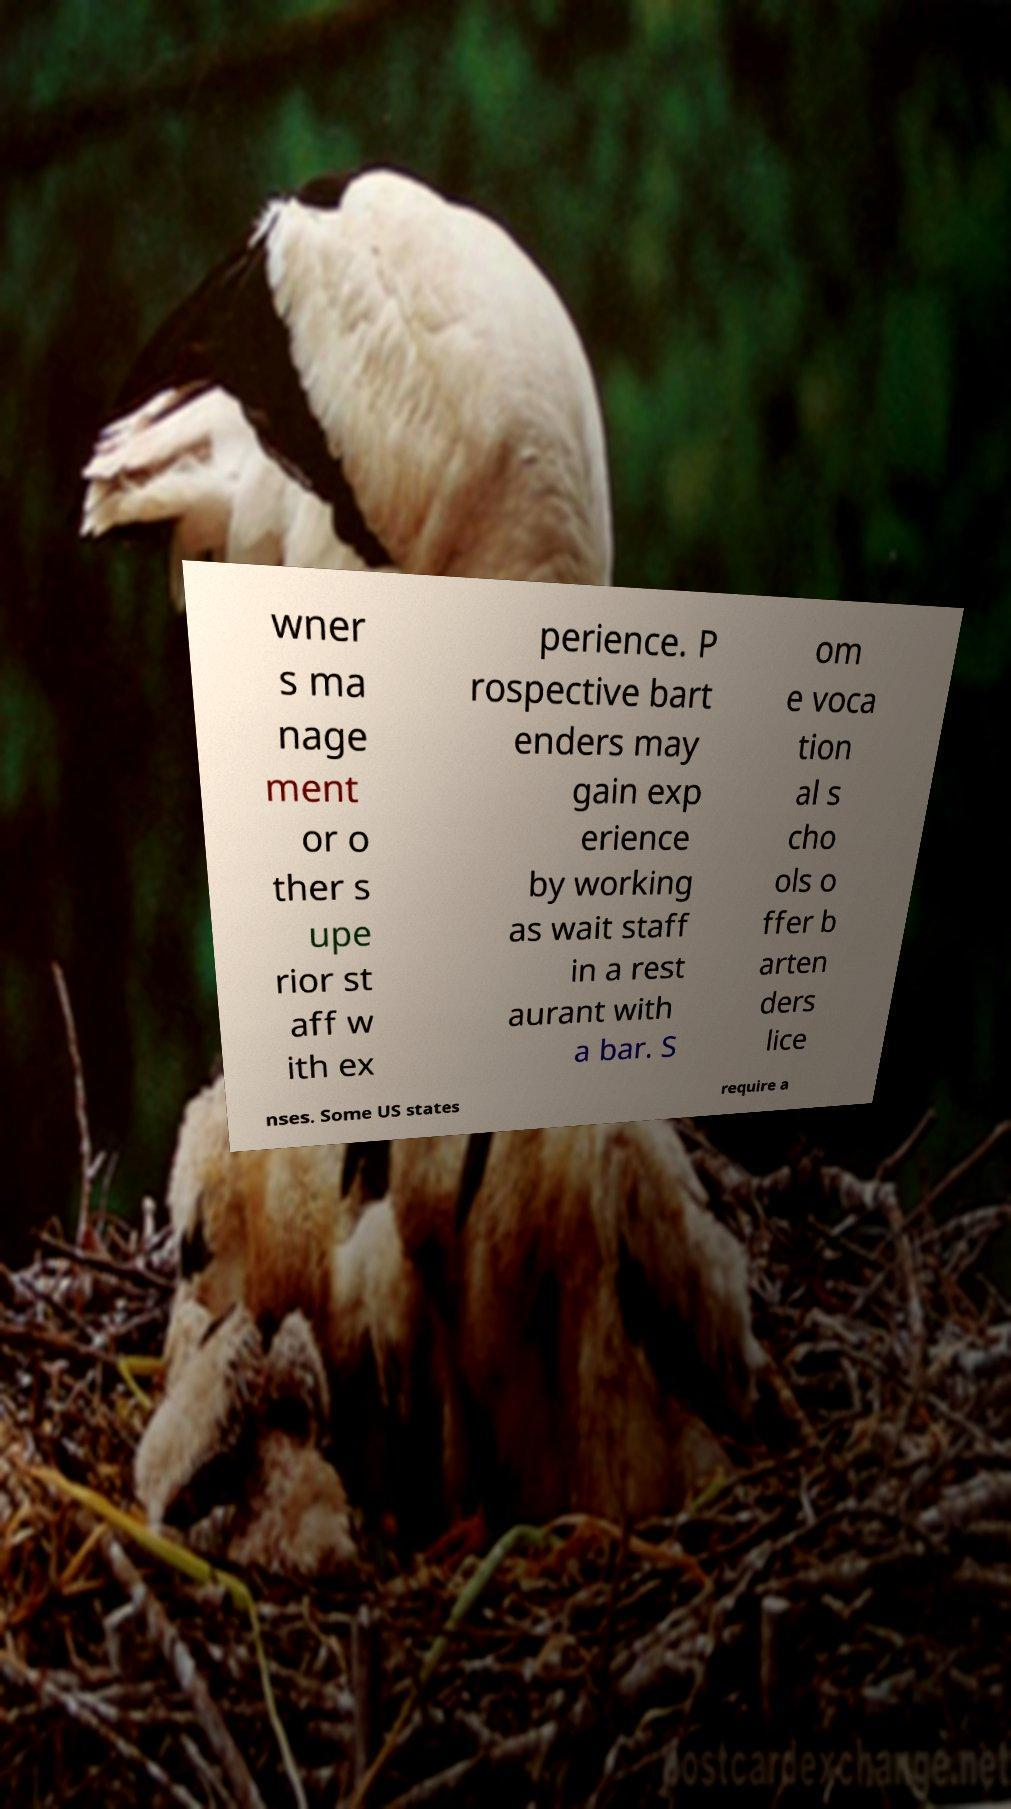Can you accurately transcribe the text from the provided image for me? wner s ma nage ment or o ther s upe rior st aff w ith ex perience. P rospective bart enders may gain exp erience by working as wait staff in a rest aurant with a bar. S om e voca tion al s cho ols o ffer b arten ders lice nses. Some US states require a 